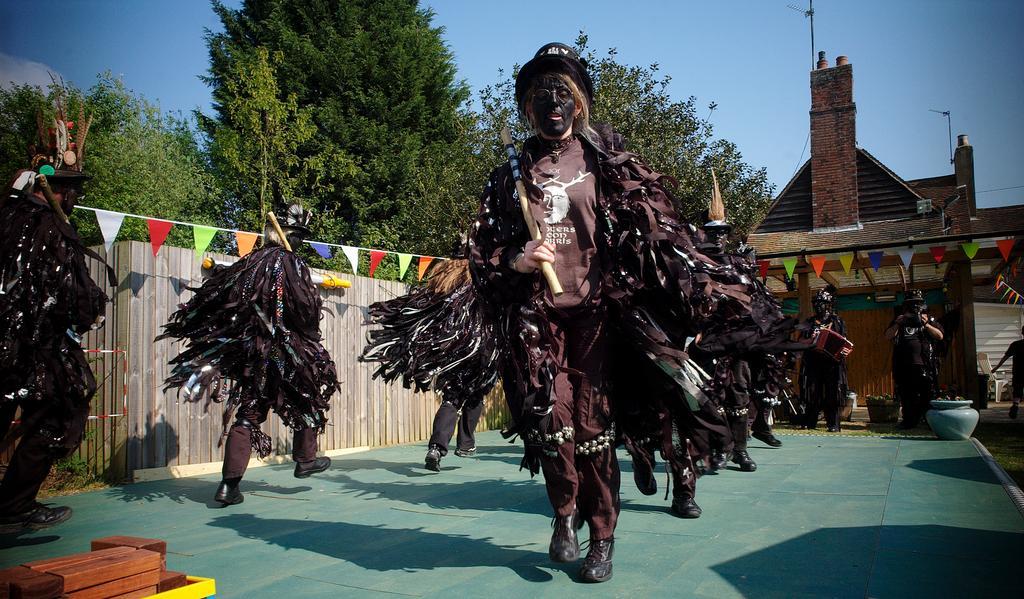Describe this image in one or two sentences. In this picture I can see few people walking and they are wearing costumes and holding sticks in their hands and I can see trees and a house in the back. I can see wooden wall on the left side and few color papers. I can see wooden blocks at the bottom of the picture and a pot on the ground. I can see a cloudy sky. 